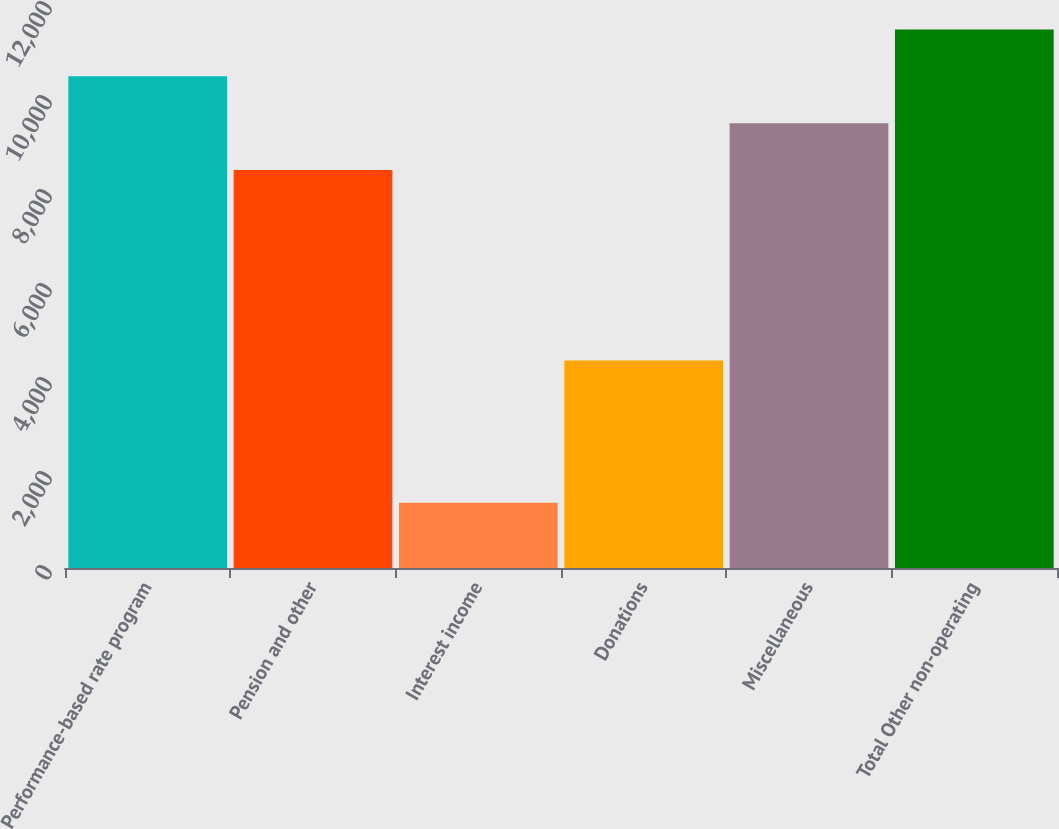Convert chart to OTSL. <chart><loc_0><loc_0><loc_500><loc_500><bar_chart><fcel>Performance-based rate program<fcel>Pension and other<fcel>Interest income<fcel>Donations<fcel>Miscellaneous<fcel>Total Other non-operating<nl><fcel>10461.4<fcel>8469<fcel>1390<fcel>4413<fcel>9465.2<fcel>11457.6<nl></chart> 